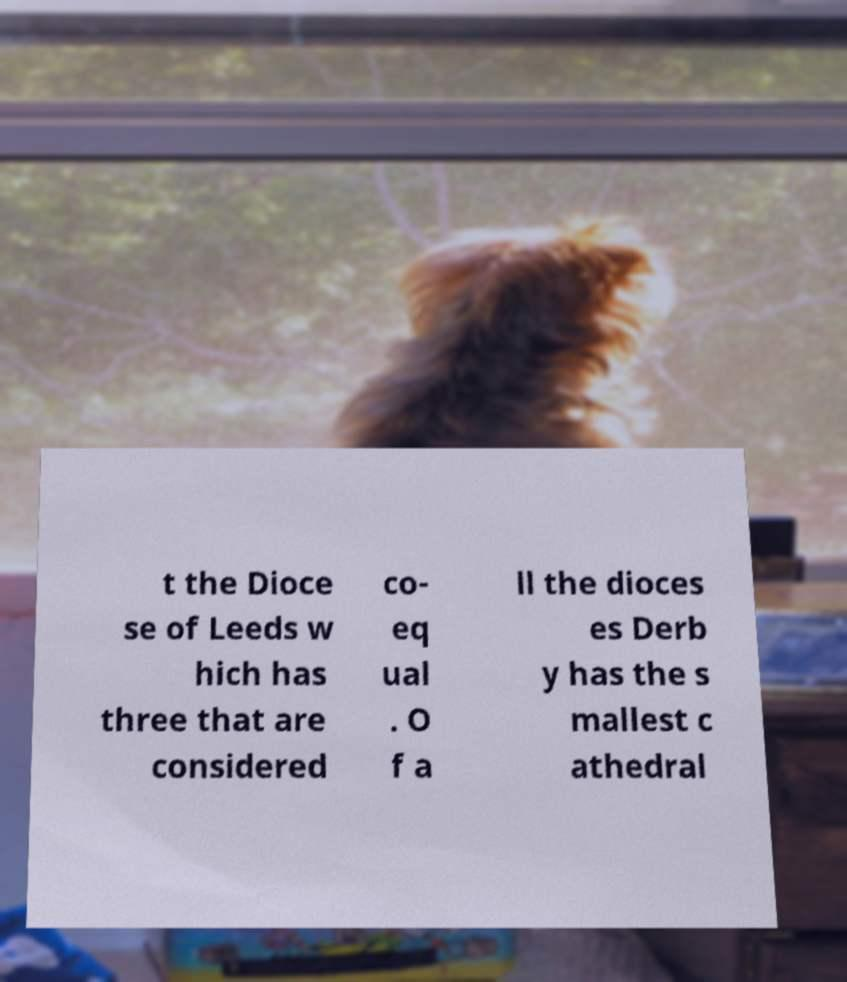I need the written content from this picture converted into text. Can you do that? t the Dioce se of Leeds w hich has three that are considered co- eq ual . O f a ll the dioces es Derb y has the s mallest c athedral 